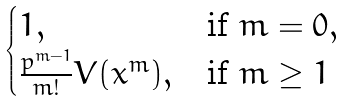<formula> <loc_0><loc_0><loc_500><loc_500>\begin{cases} 1 , & \text {if } m = 0 , \\ \frac { p ^ { m - 1 } } { m ! } V ( x ^ { m } ) , & \text {if } m \geq 1 \end{cases}</formula> 